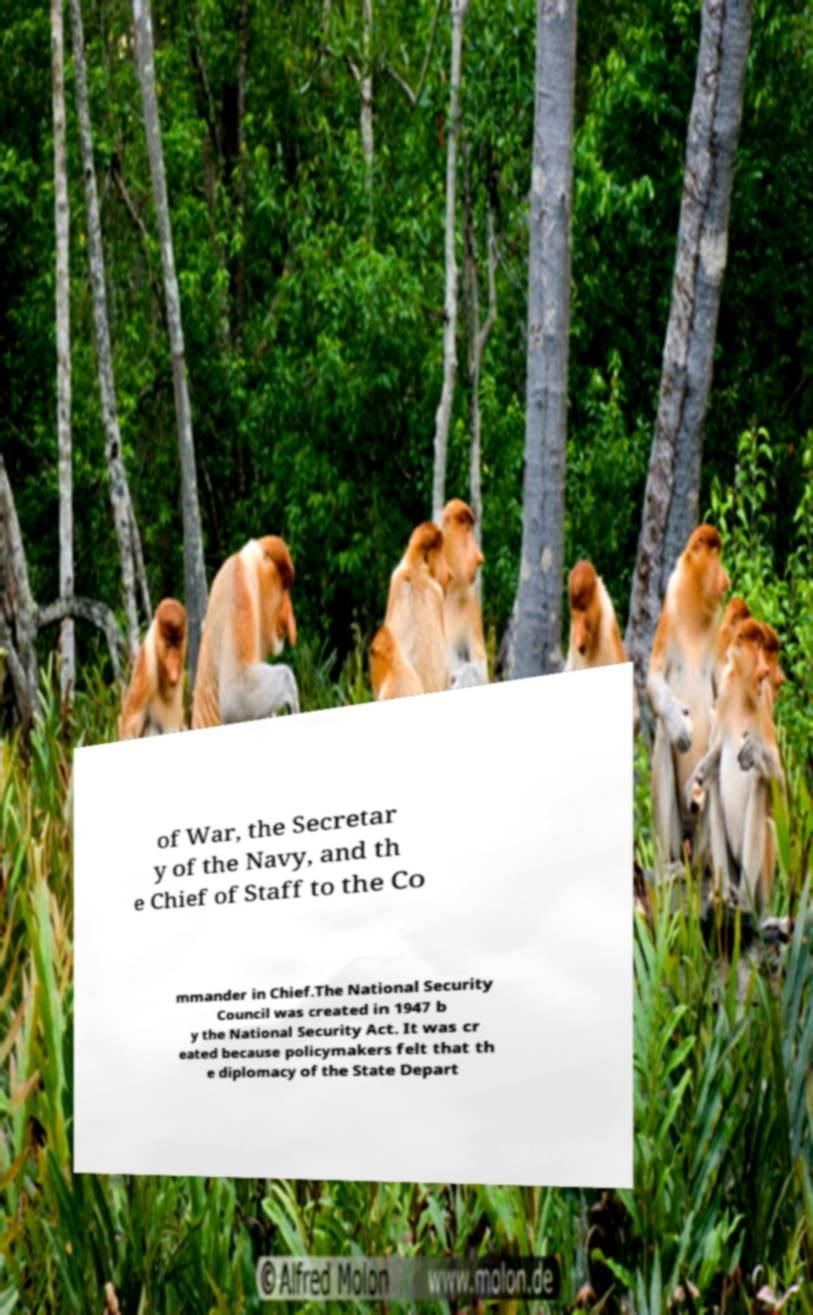Can you read and provide the text displayed in the image?This photo seems to have some interesting text. Can you extract and type it out for me? of War, the Secretar y of the Navy, and th e Chief of Staff to the Co mmander in Chief.The National Security Council was created in 1947 b y the National Security Act. It was cr eated because policymakers felt that th e diplomacy of the State Depart 